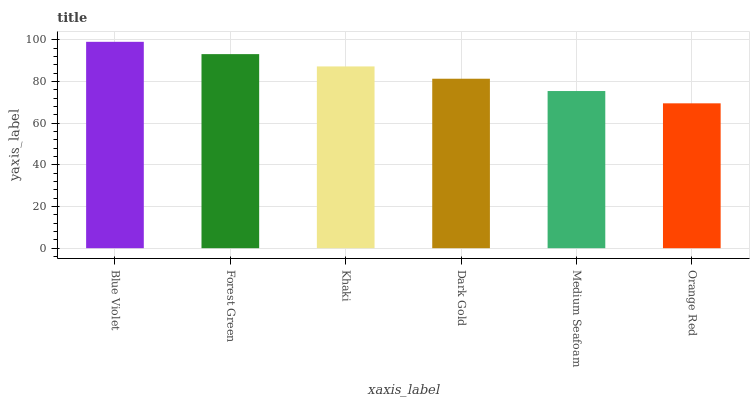Is Orange Red the minimum?
Answer yes or no. Yes. Is Blue Violet the maximum?
Answer yes or no. Yes. Is Forest Green the minimum?
Answer yes or no. No. Is Forest Green the maximum?
Answer yes or no. No. Is Blue Violet greater than Forest Green?
Answer yes or no. Yes. Is Forest Green less than Blue Violet?
Answer yes or no. Yes. Is Forest Green greater than Blue Violet?
Answer yes or no. No. Is Blue Violet less than Forest Green?
Answer yes or no. No. Is Khaki the high median?
Answer yes or no. Yes. Is Dark Gold the low median?
Answer yes or no. Yes. Is Dark Gold the high median?
Answer yes or no. No. Is Khaki the low median?
Answer yes or no. No. 